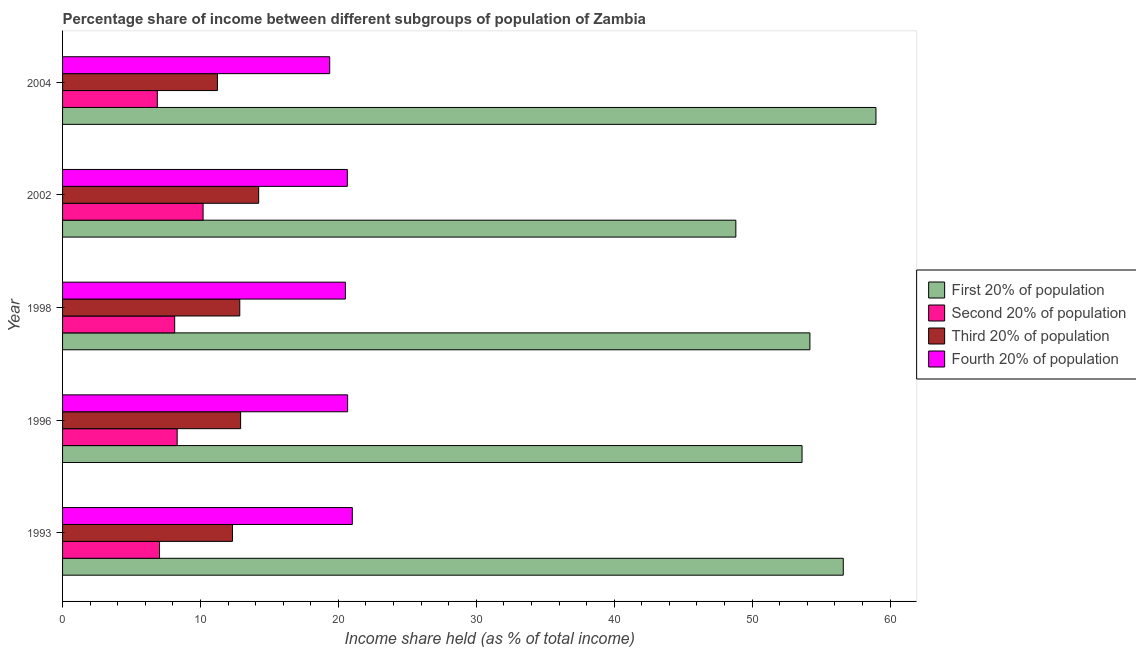How many bars are there on the 1st tick from the top?
Your response must be concise. 4. What is the label of the 5th group of bars from the top?
Ensure brevity in your answer.  1993. In how many cases, is the number of bars for a given year not equal to the number of legend labels?
Make the answer very short. 0. What is the share of the income held by second 20% of the population in 2002?
Your response must be concise. 10.19. Across all years, what is the maximum share of the income held by first 20% of the population?
Ensure brevity in your answer.  58.98. Across all years, what is the minimum share of the income held by third 20% of the population?
Your answer should be compact. 11.23. In which year was the share of the income held by third 20% of the population maximum?
Provide a succinct answer. 2002. What is the total share of the income held by fourth 20% of the population in the graph?
Your answer should be very brief. 102.21. What is the difference between the share of the income held by third 20% of the population in 1993 and that in 2002?
Keep it short and to the point. -1.9. What is the difference between the share of the income held by third 20% of the population in 2002 and the share of the income held by first 20% of the population in 1998?
Offer a very short reply. -39.97. What is the average share of the income held by third 20% of the population per year?
Give a very brief answer. 12.71. In the year 1996, what is the difference between the share of the income held by third 20% of the population and share of the income held by first 20% of the population?
Keep it short and to the point. -40.71. In how many years, is the share of the income held by first 20% of the population greater than 22 %?
Provide a short and direct response. 5. What is the ratio of the share of the income held by third 20% of the population in 2002 to that in 2004?
Provide a succinct answer. 1.27. Is the share of the income held by first 20% of the population in 1993 less than that in 2004?
Keep it short and to the point. Yes. Is the difference between the share of the income held by first 20% of the population in 1993 and 2004 greater than the difference between the share of the income held by fourth 20% of the population in 1993 and 2004?
Keep it short and to the point. No. What is the difference between the highest and the second highest share of the income held by first 20% of the population?
Your answer should be very brief. 2.37. What is the difference between the highest and the lowest share of the income held by third 20% of the population?
Ensure brevity in your answer.  2.99. In how many years, is the share of the income held by fourth 20% of the population greater than the average share of the income held by fourth 20% of the population taken over all years?
Offer a very short reply. 4. Is the sum of the share of the income held by second 20% of the population in 1993 and 1998 greater than the maximum share of the income held by first 20% of the population across all years?
Your answer should be compact. No. Is it the case that in every year, the sum of the share of the income held by second 20% of the population and share of the income held by first 20% of the population is greater than the sum of share of the income held by third 20% of the population and share of the income held by fourth 20% of the population?
Provide a succinct answer. Yes. What does the 4th bar from the top in 1998 represents?
Provide a short and direct response. First 20% of population. What does the 1st bar from the bottom in 1993 represents?
Give a very brief answer. First 20% of population. Is it the case that in every year, the sum of the share of the income held by first 20% of the population and share of the income held by second 20% of the population is greater than the share of the income held by third 20% of the population?
Ensure brevity in your answer.  Yes. How many bars are there?
Provide a succinct answer. 20. Are all the bars in the graph horizontal?
Your response must be concise. Yes. What is the difference between two consecutive major ticks on the X-axis?
Keep it short and to the point. 10. Are the values on the major ticks of X-axis written in scientific E-notation?
Give a very brief answer. No. Does the graph contain grids?
Provide a succinct answer. No. How many legend labels are there?
Offer a terse response. 4. How are the legend labels stacked?
Your answer should be compact. Vertical. What is the title of the graph?
Make the answer very short. Percentage share of income between different subgroups of population of Zambia. Does "Belgium" appear as one of the legend labels in the graph?
Ensure brevity in your answer.  No. What is the label or title of the X-axis?
Give a very brief answer. Income share held (as % of total income). What is the Income share held (as % of total income) in First 20% of population in 1993?
Provide a short and direct response. 56.61. What is the Income share held (as % of total income) in Second 20% of population in 1993?
Give a very brief answer. 7.03. What is the Income share held (as % of total income) in Third 20% of population in 1993?
Your answer should be compact. 12.32. What is the Income share held (as % of total income) of Fourth 20% of population in 1993?
Offer a terse response. 21.01. What is the Income share held (as % of total income) in First 20% of population in 1996?
Your answer should be very brief. 53.62. What is the Income share held (as % of total income) of Second 20% of population in 1996?
Offer a terse response. 8.31. What is the Income share held (as % of total income) in Third 20% of population in 1996?
Offer a terse response. 12.91. What is the Income share held (as % of total income) of Fourth 20% of population in 1996?
Provide a succinct answer. 20.67. What is the Income share held (as % of total income) of First 20% of population in 1998?
Provide a short and direct response. 54.19. What is the Income share held (as % of total income) of Second 20% of population in 1998?
Make the answer very short. 8.13. What is the Income share held (as % of total income) in Third 20% of population in 1998?
Give a very brief answer. 12.85. What is the Income share held (as % of total income) of Fourth 20% of population in 1998?
Your answer should be compact. 20.51. What is the Income share held (as % of total income) in First 20% of population in 2002?
Provide a short and direct response. 48.82. What is the Income share held (as % of total income) of Second 20% of population in 2002?
Ensure brevity in your answer.  10.19. What is the Income share held (as % of total income) of Third 20% of population in 2002?
Your response must be concise. 14.22. What is the Income share held (as % of total income) of Fourth 20% of population in 2002?
Make the answer very short. 20.65. What is the Income share held (as % of total income) of First 20% of population in 2004?
Offer a terse response. 58.98. What is the Income share held (as % of total income) in Second 20% of population in 2004?
Offer a very short reply. 6.87. What is the Income share held (as % of total income) of Third 20% of population in 2004?
Your answer should be compact. 11.23. What is the Income share held (as % of total income) in Fourth 20% of population in 2004?
Offer a very short reply. 19.37. Across all years, what is the maximum Income share held (as % of total income) of First 20% of population?
Offer a terse response. 58.98. Across all years, what is the maximum Income share held (as % of total income) in Second 20% of population?
Ensure brevity in your answer.  10.19. Across all years, what is the maximum Income share held (as % of total income) of Third 20% of population?
Provide a short and direct response. 14.22. Across all years, what is the maximum Income share held (as % of total income) of Fourth 20% of population?
Your response must be concise. 21.01. Across all years, what is the minimum Income share held (as % of total income) in First 20% of population?
Your answer should be compact. 48.82. Across all years, what is the minimum Income share held (as % of total income) in Second 20% of population?
Provide a short and direct response. 6.87. Across all years, what is the minimum Income share held (as % of total income) in Third 20% of population?
Ensure brevity in your answer.  11.23. Across all years, what is the minimum Income share held (as % of total income) in Fourth 20% of population?
Offer a very short reply. 19.37. What is the total Income share held (as % of total income) in First 20% of population in the graph?
Your answer should be very brief. 272.22. What is the total Income share held (as % of total income) in Second 20% of population in the graph?
Offer a very short reply. 40.53. What is the total Income share held (as % of total income) of Third 20% of population in the graph?
Offer a terse response. 63.53. What is the total Income share held (as % of total income) in Fourth 20% of population in the graph?
Offer a very short reply. 102.21. What is the difference between the Income share held (as % of total income) in First 20% of population in 1993 and that in 1996?
Give a very brief answer. 2.99. What is the difference between the Income share held (as % of total income) in Second 20% of population in 1993 and that in 1996?
Provide a succinct answer. -1.28. What is the difference between the Income share held (as % of total income) in Third 20% of population in 1993 and that in 1996?
Your answer should be compact. -0.59. What is the difference between the Income share held (as % of total income) of Fourth 20% of population in 1993 and that in 1996?
Your answer should be compact. 0.34. What is the difference between the Income share held (as % of total income) of First 20% of population in 1993 and that in 1998?
Your response must be concise. 2.42. What is the difference between the Income share held (as % of total income) in Third 20% of population in 1993 and that in 1998?
Your response must be concise. -0.53. What is the difference between the Income share held (as % of total income) in Fourth 20% of population in 1993 and that in 1998?
Your response must be concise. 0.5. What is the difference between the Income share held (as % of total income) in First 20% of population in 1993 and that in 2002?
Provide a succinct answer. 7.79. What is the difference between the Income share held (as % of total income) in Second 20% of population in 1993 and that in 2002?
Make the answer very short. -3.16. What is the difference between the Income share held (as % of total income) of Third 20% of population in 1993 and that in 2002?
Give a very brief answer. -1.9. What is the difference between the Income share held (as % of total income) of Fourth 20% of population in 1993 and that in 2002?
Provide a succinct answer. 0.36. What is the difference between the Income share held (as % of total income) in First 20% of population in 1993 and that in 2004?
Keep it short and to the point. -2.37. What is the difference between the Income share held (as % of total income) of Second 20% of population in 1993 and that in 2004?
Offer a very short reply. 0.16. What is the difference between the Income share held (as % of total income) in Third 20% of population in 1993 and that in 2004?
Provide a succinct answer. 1.09. What is the difference between the Income share held (as % of total income) in Fourth 20% of population in 1993 and that in 2004?
Provide a succinct answer. 1.64. What is the difference between the Income share held (as % of total income) in First 20% of population in 1996 and that in 1998?
Provide a short and direct response. -0.57. What is the difference between the Income share held (as % of total income) of Second 20% of population in 1996 and that in 1998?
Provide a short and direct response. 0.18. What is the difference between the Income share held (as % of total income) of Third 20% of population in 1996 and that in 1998?
Your response must be concise. 0.06. What is the difference between the Income share held (as % of total income) of Fourth 20% of population in 1996 and that in 1998?
Provide a succinct answer. 0.16. What is the difference between the Income share held (as % of total income) in Second 20% of population in 1996 and that in 2002?
Provide a succinct answer. -1.88. What is the difference between the Income share held (as % of total income) of Third 20% of population in 1996 and that in 2002?
Your answer should be compact. -1.31. What is the difference between the Income share held (as % of total income) in Fourth 20% of population in 1996 and that in 2002?
Your answer should be compact. 0.02. What is the difference between the Income share held (as % of total income) in First 20% of population in 1996 and that in 2004?
Keep it short and to the point. -5.36. What is the difference between the Income share held (as % of total income) of Second 20% of population in 1996 and that in 2004?
Offer a terse response. 1.44. What is the difference between the Income share held (as % of total income) in Third 20% of population in 1996 and that in 2004?
Give a very brief answer. 1.68. What is the difference between the Income share held (as % of total income) in First 20% of population in 1998 and that in 2002?
Your answer should be very brief. 5.37. What is the difference between the Income share held (as % of total income) of Second 20% of population in 1998 and that in 2002?
Make the answer very short. -2.06. What is the difference between the Income share held (as % of total income) of Third 20% of population in 1998 and that in 2002?
Give a very brief answer. -1.37. What is the difference between the Income share held (as % of total income) in Fourth 20% of population in 1998 and that in 2002?
Offer a very short reply. -0.14. What is the difference between the Income share held (as % of total income) of First 20% of population in 1998 and that in 2004?
Your response must be concise. -4.79. What is the difference between the Income share held (as % of total income) in Second 20% of population in 1998 and that in 2004?
Provide a succinct answer. 1.26. What is the difference between the Income share held (as % of total income) of Third 20% of population in 1998 and that in 2004?
Keep it short and to the point. 1.62. What is the difference between the Income share held (as % of total income) in Fourth 20% of population in 1998 and that in 2004?
Give a very brief answer. 1.14. What is the difference between the Income share held (as % of total income) of First 20% of population in 2002 and that in 2004?
Offer a very short reply. -10.16. What is the difference between the Income share held (as % of total income) in Second 20% of population in 2002 and that in 2004?
Offer a very short reply. 3.32. What is the difference between the Income share held (as % of total income) of Third 20% of population in 2002 and that in 2004?
Your answer should be very brief. 2.99. What is the difference between the Income share held (as % of total income) of Fourth 20% of population in 2002 and that in 2004?
Provide a short and direct response. 1.28. What is the difference between the Income share held (as % of total income) in First 20% of population in 1993 and the Income share held (as % of total income) in Second 20% of population in 1996?
Make the answer very short. 48.3. What is the difference between the Income share held (as % of total income) in First 20% of population in 1993 and the Income share held (as % of total income) in Third 20% of population in 1996?
Make the answer very short. 43.7. What is the difference between the Income share held (as % of total income) of First 20% of population in 1993 and the Income share held (as % of total income) of Fourth 20% of population in 1996?
Offer a terse response. 35.94. What is the difference between the Income share held (as % of total income) of Second 20% of population in 1993 and the Income share held (as % of total income) of Third 20% of population in 1996?
Provide a succinct answer. -5.88. What is the difference between the Income share held (as % of total income) in Second 20% of population in 1993 and the Income share held (as % of total income) in Fourth 20% of population in 1996?
Your answer should be compact. -13.64. What is the difference between the Income share held (as % of total income) in Third 20% of population in 1993 and the Income share held (as % of total income) in Fourth 20% of population in 1996?
Provide a succinct answer. -8.35. What is the difference between the Income share held (as % of total income) of First 20% of population in 1993 and the Income share held (as % of total income) of Second 20% of population in 1998?
Make the answer very short. 48.48. What is the difference between the Income share held (as % of total income) in First 20% of population in 1993 and the Income share held (as % of total income) in Third 20% of population in 1998?
Provide a succinct answer. 43.76. What is the difference between the Income share held (as % of total income) in First 20% of population in 1993 and the Income share held (as % of total income) in Fourth 20% of population in 1998?
Make the answer very short. 36.1. What is the difference between the Income share held (as % of total income) in Second 20% of population in 1993 and the Income share held (as % of total income) in Third 20% of population in 1998?
Offer a very short reply. -5.82. What is the difference between the Income share held (as % of total income) of Second 20% of population in 1993 and the Income share held (as % of total income) of Fourth 20% of population in 1998?
Give a very brief answer. -13.48. What is the difference between the Income share held (as % of total income) of Third 20% of population in 1993 and the Income share held (as % of total income) of Fourth 20% of population in 1998?
Your answer should be very brief. -8.19. What is the difference between the Income share held (as % of total income) in First 20% of population in 1993 and the Income share held (as % of total income) in Second 20% of population in 2002?
Provide a short and direct response. 46.42. What is the difference between the Income share held (as % of total income) of First 20% of population in 1993 and the Income share held (as % of total income) of Third 20% of population in 2002?
Give a very brief answer. 42.39. What is the difference between the Income share held (as % of total income) in First 20% of population in 1993 and the Income share held (as % of total income) in Fourth 20% of population in 2002?
Ensure brevity in your answer.  35.96. What is the difference between the Income share held (as % of total income) in Second 20% of population in 1993 and the Income share held (as % of total income) in Third 20% of population in 2002?
Your response must be concise. -7.19. What is the difference between the Income share held (as % of total income) in Second 20% of population in 1993 and the Income share held (as % of total income) in Fourth 20% of population in 2002?
Make the answer very short. -13.62. What is the difference between the Income share held (as % of total income) of Third 20% of population in 1993 and the Income share held (as % of total income) of Fourth 20% of population in 2002?
Your answer should be compact. -8.33. What is the difference between the Income share held (as % of total income) in First 20% of population in 1993 and the Income share held (as % of total income) in Second 20% of population in 2004?
Ensure brevity in your answer.  49.74. What is the difference between the Income share held (as % of total income) in First 20% of population in 1993 and the Income share held (as % of total income) in Third 20% of population in 2004?
Keep it short and to the point. 45.38. What is the difference between the Income share held (as % of total income) of First 20% of population in 1993 and the Income share held (as % of total income) of Fourth 20% of population in 2004?
Your answer should be very brief. 37.24. What is the difference between the Income share held (as % of total income) of Second 20% of population in 1993 and the Income share held (as % of total income) of Third 20% of population in 2004?
Ensure brevity in your answer.  -4.2. What is the difference between the Income share held (as % of total income) in Second 20% of population in 1993 and the Income share held (as % of total income) in Fourth 20% of population in 2004?
Offer a terse response. -12.34. What is the difference between the Income share held (as % of total income) of Third 20% of population in 1993 and the Income share held (as % of total income) of Fourth 20% of population in 2004?
Make the answer very short. -7.05. What is the difference between the Income share held (as % of total income) in First 20% of population in 1996 and the Income share held (as % of total income) in Second 20% of population in 1998?
Ensure brevity in your answer.  45.49. What is the difference between the Income share held (as % of total income) in First 20% of population in 1996 and the Income share held (as % of total income) in Third 20% of population in 1998?
Offer a terse response. 40.77. What is the difference between the Income share held (as % of total income) in First 20% of population in 1996 and the Income share held (as % of total income) in Fourth 20% of population in 1998?
Ensure brevity in your answer.  33.11. What is the difference between the Income share held (as % of total income) in Second 20% of population in 1996 and the Income share held (as % of total income) in Third 20% of population in 1998?
Your response must be concise. -4.54. What is the difference between the Income share held (as % of total income) in Second 20% of population in 1996 and the Income share held (as % of total income) in Fourth 20% of population in 1998?
Provide a succinct answer. -12.2. What is the difference between the Income share held (as % of total income) in First 20% of population in 1996 and the Income share held (as % of total income) in Second 20% of population in 2002?
Ensure brevity in your answer.  43.43. What is the difference between the Income share held (as % of total income) of First 20% of population in 1996 and the Income share held (as % of total income) of Third 20% of population in 2002?
Ensure brevity in your answer.  39.4. What is the difference between the Income share held (as % of total income) in First 20% of population in 1996 and the Income share held (as % of total income) in Fourth 20% of population in 2002?
Offer a terse response. 32.97. What is the difference between the Income share held (as % of total income) in Second 20% of population in 1996 and the Income share held (as % of total income) in Third 20% of population in 2002?
Your response must be concise. -5.91. What is the difference between the Income share held (as % of total income) of Second 20% of population in 1996 and the Income share held (as % of total income) of Fourth 20% of population in 2002?
Your answer should be compact. -12.34. What is the difference between the Income share held (as % of total income) in Third 20% of population in 1996 and the Income share held (as % of total income) in Fourth 20% of population in 2002?
Your response must be concise. -7.74. What is the difference between the Income share held (as % of total income) of First 20% of population in 1996 and the Income share held (as % of total income) of Second 20% of population in 2004?
Provide a succinct answer. 46.75. What is the difference between the Income share held (as % of total income) of First 20% of population in 1996 and the Income share held (as % of total income) of Third 20% of population in 2004?
Make the answer very short. 42.39. What is the difference between the Income share held (as % of total income) in First 20% of population in 1996 and the Income share held (as % of total income) in Fourth 20% of population in 2004?
Make the answer very short. 34.25. What is the difference between the Income share held (as % of total income) in Second 20% of population in 1996 and the Income share held (as % of total income) in Third 20% of population in 2004?
Ensure brevity in your answer.  -2.92. What is the difference between the Income share held (as % of total income) in Second 20% of population in 1996 and the Income share held (as % of total income) in Fourth 20% of population in 2004?
Make the answer very short. -11.06. What is the difference between the Income share held (as % of total income) of Third 20% of population in 1996 and the Income share held (as % of total income) of Fourth 20% of population in 2004?
Offer a very short reply. -6.46. What is the difference between the Income share held (as % of total income) in First 20% of population in 1998 and the Income share held (as % of total income) in Second 20% of population in 2002?
Your answer should be very brief. 44. What is the difference between the Income share held (as % of total income) in First 20% of population in 1998 and the Income share held (as % of total income) in Third 20% of population in 2002?
Your answer should be very brief. 39.97. What is the difference between the Income share held (as % of total income) of First 20% of population in 1998 and the Income share held (as % of total income) of Fourth 20% of population in 2002?
Make the answer very short. 33.54. What is the difference between the Income share held (as % of total income) of Second 20% of population in 1998 and the Income share held (as % of total income) of Third 20% of population in 2002?
Keep it short and to the point. -6.09. What is the difference between the Income share held (as % of total income) in Second 20% of population in 1998 and the Income share held (as % of total income) in Fourth 20% of population in 2002?
Your answer should be compact. -12.52. What is the difference between the Income share held (as % of total income) in First 20% of population in 1998 and the Income share held (as % of total income) in Second 20% of population in 2004?
Provide a short and direct response. 47.32. What is the difference between the Income share held (as % of total income) in First 20% of population in 1998 and the Income share held (as % of total income) in Third 20% of population in 2004?
Offer a very short reply. 42.96. What is the difference between the Income share held (as % of total income) in First 20% of population in 1998 and the Income share held (as % of total income) in Fourth 20% of population in 2004?
Provide a short and direct response. 34.82. What is the difference between the Income share held (as % of total income) in Second 20% of population in 1998 and the Income share held (as % of total income) in Fourth 20% of population in 2004?
Make the answer very short. -11.24. What is the difference between the Income share held (as % of total income) in Third 20% of population in 1998 and the Income share held (as % of total income) in Fourth 20% of population in 2004?
Keep it short and to the point. -6.52. What is the difference between the Income share held (as % of total income) of First 20% of population in 2002 and the Income share held (as % of total income) of Second 20% of population in 2004?
Offer a terse response. 41.95. What is the difference between the Income share held (as % of total income) of First 20% of population in 2002 and the Income share held (as % of total income) of Third 20% of population in 2004?
Provide a succinct answer. 37.59. What is the difference between the Income share held (as % of total income) in First 20% of population in 2002 and the Income share held (as % of total income) in Fourth 20% of population in 2004?
Offer a very short reply. 29.45. What is the difference between the Income share held (as % of total income) in Second 20% of population in 2002 and the Income share held (as % of total income) in Third 20% of population in 2004?
Your response must be concise. -1.04. What is the difference between the Income share held (as % of total income) of Second 20% of population in 2002 and the Income share held (as % of total income) of Fourth 20% of population in 2004?
Give a very brief answer. -9.18. What is the difference between the Income share held (as % of total income) in Third 20% of population in 2002 and the Income share held (as % of total income) in Fourth 20% of population in 2004?
Your answer should be compact. -5.15. What is the average Income share held (as % of total income) of First 20% of population per year?
Give a very brief answer. 54.44. What is the average Income share held (as % of total income) of Second 20% of population per year?
Keep it short and to the point. 8.11. What is the average Income share held (as % of total income) in Third 20% of population per year?
Provide a succinct answer. 12.71. What is the average Income share held (as % of total income) of Fourth 20% of population per year?
Offer a terse response. 20.44. In the year 1993, what is the difference between the Income share held (as % of total income) of First 20% of population and Income share held (as % of total income) of Second 20% of population?
Make the answer very short. 49.58. In the year 1993, what is the difference between the Income share held (as % of total income) of First 20% of population and Income share held (as % of total income) of Third 20% of population?
Offer a terse response. 44.29. In the year 1993, what is the difference between the Income share held (as % of total income) of First 20% of population and Income share held (as % of total income) of Fourth 20% of population?
Your answer should be compact. 35.6. In the year 1993, what is the difference between the Income share held (as % of total income) of Second 20% of population and Income share held (as % of total income) of Third 20% of population?
Provide a short and direct response. -5.29. In the year 1993, what is the difference between the Income share held (as % of total income) of Second 20% of population and Income share held (as % of total income) of Fourth 20% of population?
Keep it short and to the point. -13.98. In the year 1993, what is the difference between the Income share held (as % of total income) of Third 20% of population and Income share held (as % of total income) of Fourth 20% of population?
Keep it short and to the point. -8.69. In the year 1996, what is the difference between the Income share held (as % of total income) of First 20% of population and Income share held (as % of total income) of Second 20% of population?
Provide a short and direct response. 45.31. In the year 1996, what is the difference between the Income share held (as % of total income) of First 20% of population and Income share held (as % of total income) of Third 20% of population?
Your answer should be compact. 40.71. In the year 1996, what is the difference between the Income share held (as % of total income) in First 20% of population and Income share held (as % of total income) in Fourth 20% of population?
Provide a succinct answer. 32.95. In the year 1996, what is the difference between the Income share held (as % of total income) of Second 20% of population and Income share held (as % of total income) of Fourth 20% of population?
Your response must be concise. -12.36. In the year 1996, what is the difference between the Income share held (as % of total income) of Third 20% of population and Income share held (as % of total income) of Fourth 20% of population?
Make the answer very short. -7.76. In the year 1998, what is the difference between the Income share held (as % of total income) in First 20% of population and Income share held (as % of total income) in Second 20% of population?
Offer a very short reply. 46.06. In the year 1998, what is the difference between the Income share held (as % of total income) of First 20% of population and Income share held (as % of total income) of Third 20% of population?
Your response must be concise. 41.34. In the year 1998, what is the difference between the Income share held (as % of total income) in First 20% of population and Income share held (as % of total income) in Fourth 20% of population?
Provide a short and direct response. 33.68. In the year 1998, what is the difference between the Income share held (as % of total income) in Second 20% of population and Income share held (as % of total income) in Third 20% of population?
Ensure brevity in your answer.  -4.72. In the year 1998, what is the difference between the Income share held (as % of total income) of Second 20% of population and Income share held (as % of total income) of Fourth 20% of population?
Provide a short and direct response. -12.38. In the year 1998, what is the difference between the Income share held (as % of total income) in Third 20% of population and Income share held (as % of total income) in Fourth 20% of population?
Ensure brevity in your answer.  -7.66. In the year 2002, what is the difference between the Income share held (as % of total income) in First 20% of population and Income share held (as % of total income) in Second 20% of population?
Ensure brevity in your answer.  38.63. In the year 2002, what is the difference between the Income share held (as % of total income) in First 20% of population and Income share held (as % of total income) in Third 20% of population?
Keep it short and to the point. 34.6. In the year 2002, what is the difference between the Income share held (as % of total income) in First 20% of population and Income share held (as % of total income) in Fourth 20% of population?
Your answer should be compact. 28.17. In the year 2002, what is the difference between the Income share held (as % of total income) of Second 20% of population and Income share held (as % of total income) of Third 20% of population?
Offer a very short reply. -4.03. In the year 2002, what is the difference between the Income share held (as % of total income) in Second 20% of population and Income share held (as % of total income) in Fourth 20% of population?
Make the answer very short. -10.46. In the year 2002, what is the difference between the Income share held (as % of total income) of Third 20% of population and Income share held (as % of total income) of Fourth 20% of population?
Provide a succinct answer. -6.43. In the year 2004, what is the difference between the Income share held (as % of total income) in First 20% of population and Income share held (as % of total income) in Second 20% of population?
Offer a very short reply. 52.11. In the year 2004, what is the difference between the Income share held (as % of total income) of First 20% of population and Income share held (as % of total income) of Third 20% of population?
Provide a succinct answer. 47.75. In the year 2004, what is the difference between the Income share held (as % of total income) of First 20% of population and Income share held (as % of total income) of Fourth 20% of population?
Ensure brevity in your answer.  39.61. In the year 2004, what is the difference between the Income share held (as % of total income) of Second 20% of population and Income share held (as % of total income) of Third 20% of population?
Give a very brief answer. -4.36. In the year 2004, what is the difference between the Income share held (as % of total income) in Third 20% of population and Income share held (as % of total income) in Fourth 20% of population?
Your answer should be very brief. -8.14. What is the ratio of the Income share held (as % of total income) in First 20% of population in 1993 to that in 1996?
Make the answer very short. 1.06. What is the ratio of the Income share held (as % of total income) in Second 20% of population in 1993 to that in 1996?
Offer a very short reply. 0.85. What is the ratio of the Income share held (as % of total income) in Third 20% of population in 1993 to that in 1996?
Make the answer very short. 0.95. What is the ratio of the Income share held (as % of total income) of Fourth 20% of population in 1993 to that in 1996?
Offer a very short reply. 1.02. What is the ratio of the Income share held (as % of total income) of First 20% of population in 1993 to that in 1998?
Your response must be concise. 1.04. What is the ratio of the Income share held (as % of total income) in Second 20% of population in 1993 to that in 1998?
Provide a short and direct response. 0.86. What is the ratio of the Income share held (as % of total income) of Third 20% of population in 1993 to that in 1998?
Give a very brief answer. 0.96. What is the ratio of the Income share held (as % of total income) in Fourth 20% of population in 1993 to that in 1998?
Your answer should be compact. 1.02. What is the ratio of the Income share held (as % of total income) of First 20% of population in 1993 to that in 2002?
Give a very brief answer. 1.16. What is the ratio of the Income share held (as % of total income) of Second 20% of population in 1993 to that in 2002?
Make the answer very short. 0.69. What is the ratio of the Income share held (as % of total income) of Third 20% of population in 1993 to that in 2002?
Provide a succinct answer. 0.87. What is the ratio of the Income share held (as % of total income) of Fourth 20% of population in 1993 to that in 2002?
Offer a very short reply. 1.02. What is the ratio of the Income share held (as % of total income) in First 20% of population in 1993 to that in 2004?
Keep it short and to the point. 0.96. What is the ratio of the Income share held (as % of total income) of Second 20% of population in 1993 to that in 2004?
Make the answer very short. 1.02. What is the ratio of the Income share held (as % of total income) in Third 20% of population in 1993 to that in 2004?
Give a very brief answer. 1.1. What is the ratio of the Income share held (as % of total income) in Fourth 20% of population in 1993 to that in 2004?
Ensure brevity in your answer.  1.08. What is the ratio of the Income share held (as % of total income) in Second 20% of population in 1996 to that in 1998?
Offer a terse response. 1.02. What is the ratio of the Income share held (as % of total income) of Third 20% of population in 1996 to that in 1998?
Your answer should be compact. 1. What is the ratio of the Income share held (as % of total income) of First 20% of population in 1996 to that in 2002?
Give a very brief answer. 1.1. What is the ratio of the Income share held (as % of total income) in Second 20% of population in 1996 to that in 2002?
Your answer should be compact. 0.82. What is the ratio of the Income share held (as % of total income) of Third 20% of population in 1996 to that in 2002?
Your answer should be very brief. 0.91. What is the ratio of the Income share held (as % of total income) in First 20% of population in 1996 to that in 2004?
Give a very brief answer. 0.91. What is the ratio of the Income share held (as % of total income) in Second 20% of population in 1996 to that in 2004?
Offer a terse response. 1.21. What is the ratio of the Income share held (as % of total income) of Third 20% of population in 1996 to that in 2004?
Your response must be concise. 1.15. What is the ratio of the Income share held (as % of total income) of Fourth 20% of population in 1996 to that in 2004?
Ensure brevity in your answer.  1.07. What is the ratio of the Income share held (as % of total income) in First 20% of population in 1998 to that in 2002?
Offer a terse response. 1.11. What is the ratio of the Income share held (as % of total income) in Second 20% of population in 1998 to that in 2002?
Make the answer very short. 0.8. What is the ratio of the Income share held (as % of total income) in Third 20% of population in 1998 to that in 2002?
Your answer should be very brief. 0.9. What is the ratio of the Income share held (as % of total income) of Fourth 20% of population in 1998 to that in 2002?
Your answer should be very brief. 0.99. What is the ratio of the Income share held (as % of total income) of First 20% of population in 1998 to that in 2004?
Provide a short and direct response. 0.92. What is the ratio of the Income share held (as % of total income) in Second 20% of population in 1998 to that in 2004?
Ensure brevity in your answer.  1.18. What is the ratio of the Income share held (as % of total income) of Third 20% of population in 1998 to that in 2004?
Your answer should be compact. 1.14. What is the ratio of the Income share held (as % of total income) of Fourth 20% of population in 1998 to that in 2004?
Your answer should be very brief. 1.06. What is the ratio of the Income share held (as % of total income) in First 20% of population in 2002 to that in 2004?
Provide a short and direct response. 0.83. What is the ratio of the Income share held (as % of total income) in Second 20% of population in 2002 to that in 2004?
Make the answer very short. 1.48. What is the ratio of the Income share held (as % of total income) in Third 20% of population in 2002 to that in 2004?
Provide a short and direct response. 1.27. What is the ratio of the Income share held (as % of total income) of Fourth 20% of population in 2002 to that in 2004?
Ensure brevity in your answer.  1.07. What is the difference between the highest and the second highest Income share held (as % of total income) in First 20% of population?
Ensure brevity in your answer.  2.37. What is the difference between the highest and the second highest Income share held (as % of total income) of Second 20% of population?
Ensure brevity in your answer.  1.88. What is the difference between the highest and the second highest Income share held (as % of total income) of Third 20% of population?
Provide a short and direct response. 1.31. What is the difference between the highest and the second highest Income share held (as % of total income) of Fourth 20% of population?
Your answer should be very brief. 0.34. What is the difference between the highest and the lowest Income share held (as % of total income) in First 20% of population?
Keep it short and to the point. 10.16. What is the difference between the highest and the lowest Income share held (as % of total income) of Second 20% of population?
Your answer should be very brief. 3.32. What is the difference between the highest and the lowest Income share held (as % of total income) of Third 20% of population?
Keep it short and to the point. 2.99. What is the difference between the highest and the lowest Income share held (as % of total income) in Fourth 20% of population?
Provide a short and direct response. 1.64. 